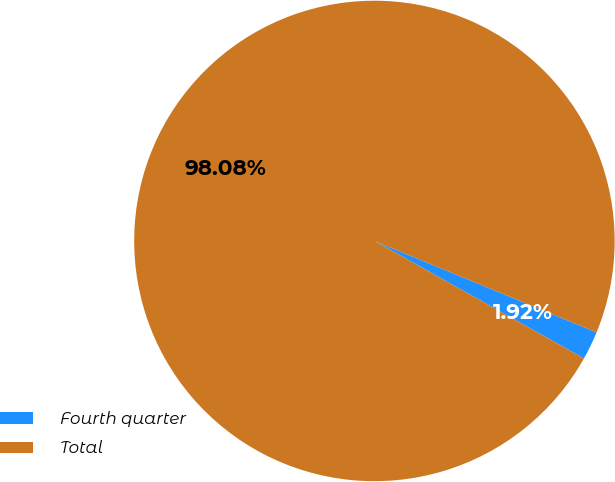<chart> <loc_0><loc_0><loc_500><loc_500><pie_chart><fcel>Fourth quarter<fcel>Total<nl><fcel>1.92%<fcel>98.08%<nl></chart> 